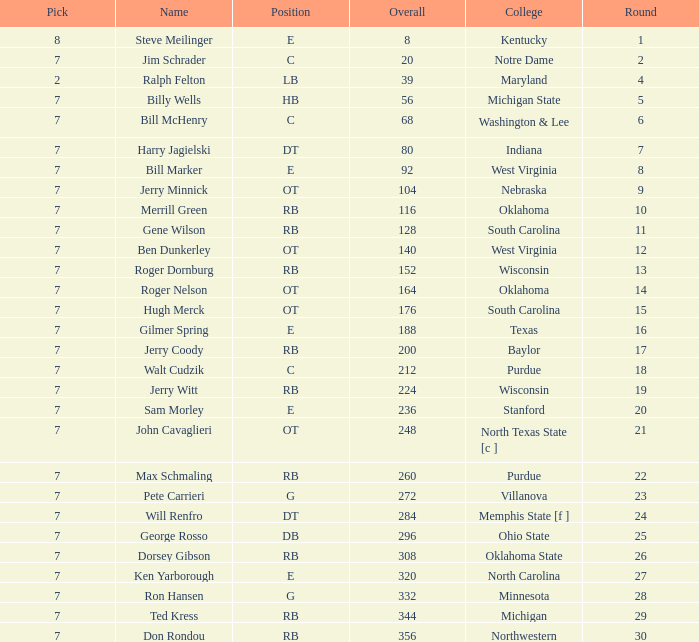What pick did George Rosso get drafted when the overall was less than 296? 0.0. 